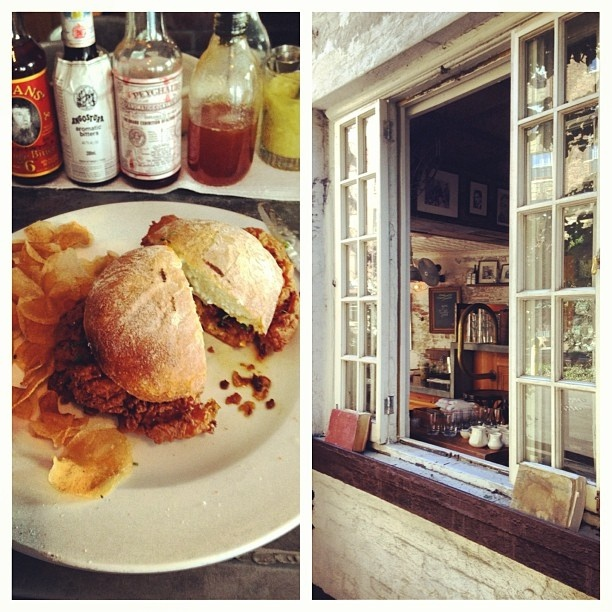Describe the objects in this image and their specific colors. I can see sandwich in ivory, maroon, tan, and brown tones, sandwich in ivory, tan, lightyellow, and maroon tones, bottle in ivory, beige, tan, and gray tones, bottle in ivory, maroon, tan, beige, and brown tones, and bottle in ivory, beige, darkgray, and gray tones in this image. 